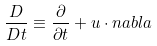<formula> <loc_0><loc_0><loc_500><loc_500>\frac { D } { D t } \equiv \frac { \partial } { \partial t } + u \cdot n a b l a</formula> 